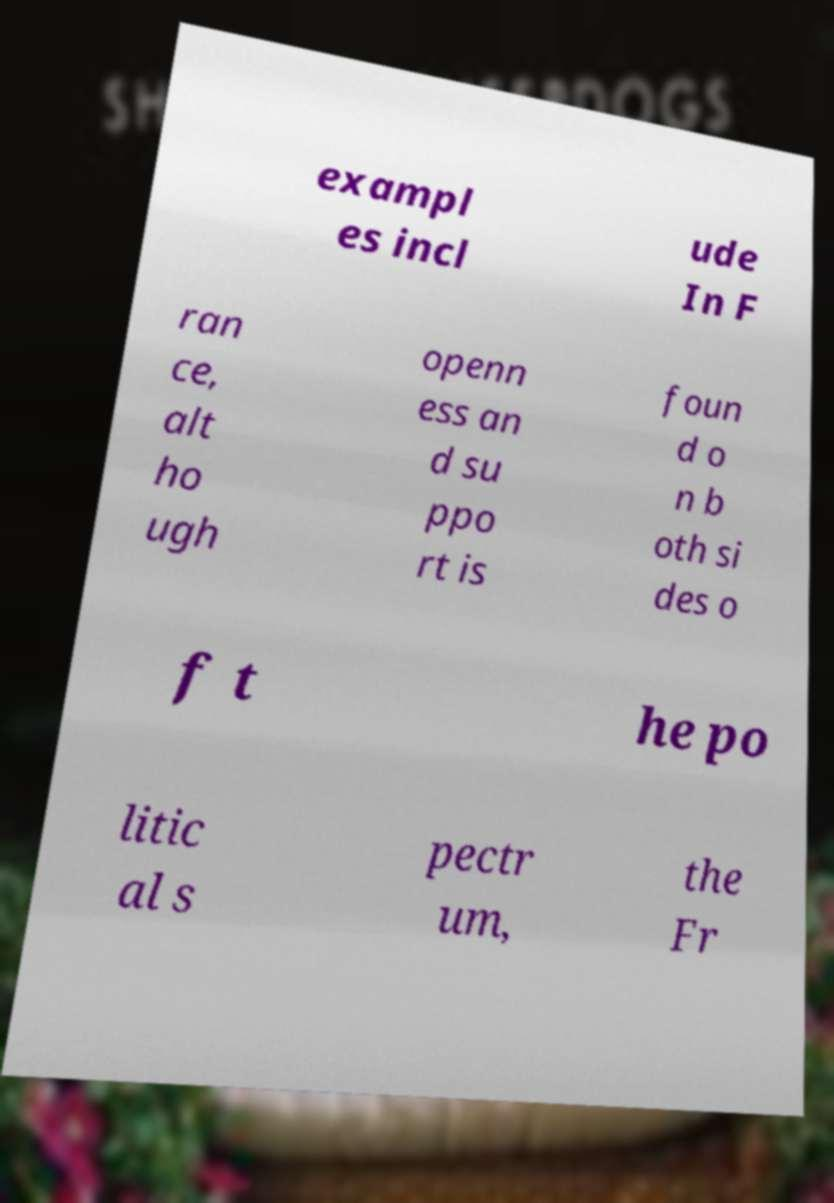Could you assist in decoding the text presented in this image and type it out clearly? exampl es incl ude In F ran ce, alt ho ugh openn ess an d su ppo rt is foun d o n b oth si des o f t he po litic al s pectr um, the Fr 